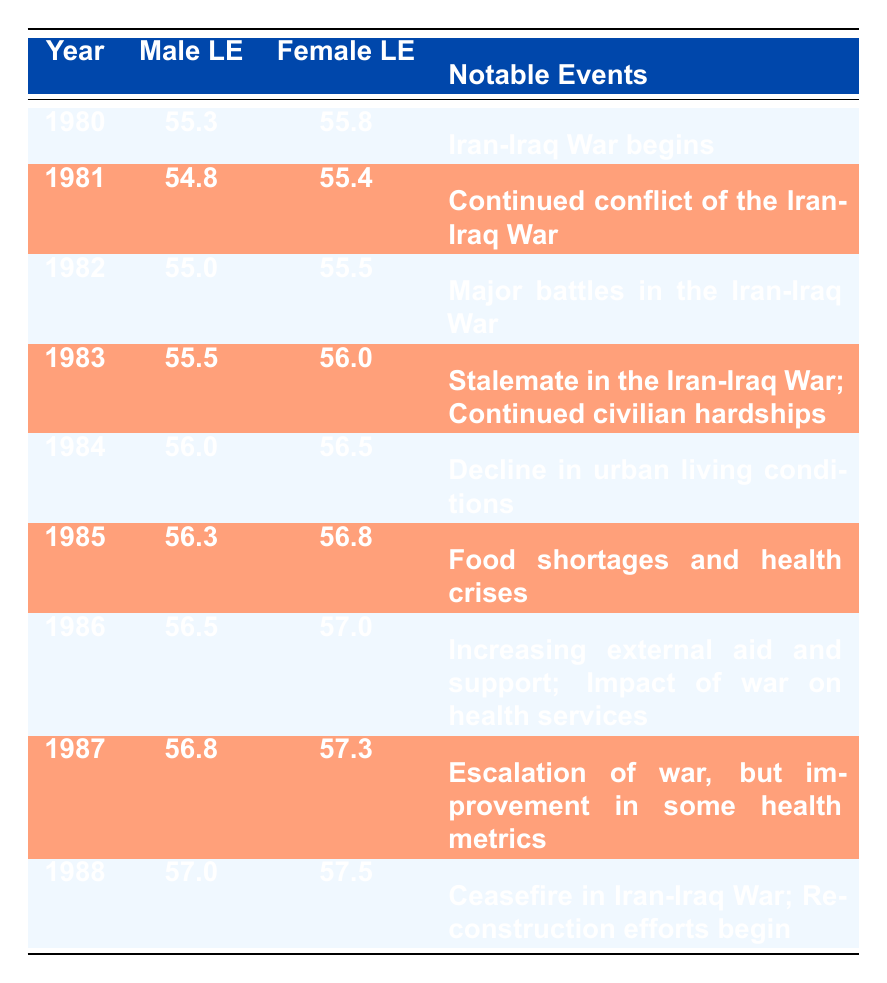What was the life expectancy for males in Iran in 1983? Referring to the table, the life expectancy for males in 1983 is noted as 55.5.
Answer: 55.5 What notable event occurred in 1986? According to the table, the notable events for 1986 include increasing external aid and support, as well as the impact of war on health services.
Answer: Increasing external aid and support; Impact of war on health services Did life expectancy for females increase from 1984 to 1985? In the table, the values show female life expectancy was 56.5 in 1984 and increased to 56.8 in 1985; therefore, it did increase.
Answer: Yes What is the average life expectancy for males during the years 1980 to 1982? The male life expectancies for those years are 55.3 (1980), 54.8 (1981), and 55.0 (1982). The sum is 55.3 + 54.8 + 55.0 = 165.1 and the average is 165.1 / 3 = 55.033.
Answer: 55.033 Was there a decrease in male life expectancy from 1980 to 1981? Looking at the values, male life expectancy fell from 55.3 in 1980 to 54.8 in 1981, indicating a decrease.
Answer: Yes What was the highest life expectancy recorded for females in the table? Checking each female life expectancy, the highest value is 57.5 in 1988.
Answer: 57.5 Compare the life expectancy for males in 1985 to 1987 - was it higher in 1987? For males, life expectancy was 56.3 in 1985 and 56.8 in 1987; therefore, it was indeed higher in 1987.
Answer: Yes What was the life expectancy change for females from 1982 to 1983? In 1982, the female life expectancy was 55.5, and in 1983, it was 56.0. The change is 56.0 - 55.5 = 0.5.
Answer: Increased by 0.5 Which notable event in 1988 likely contributed to increased life expectancy? The table indicates that in 1988 there was a ceasefire in the Iran-Iraq War and reconstruction efforts began, both likely contributing positively.
Answer: Ceasefire in Iran-Iraq War; Reconstruction efforts begin 